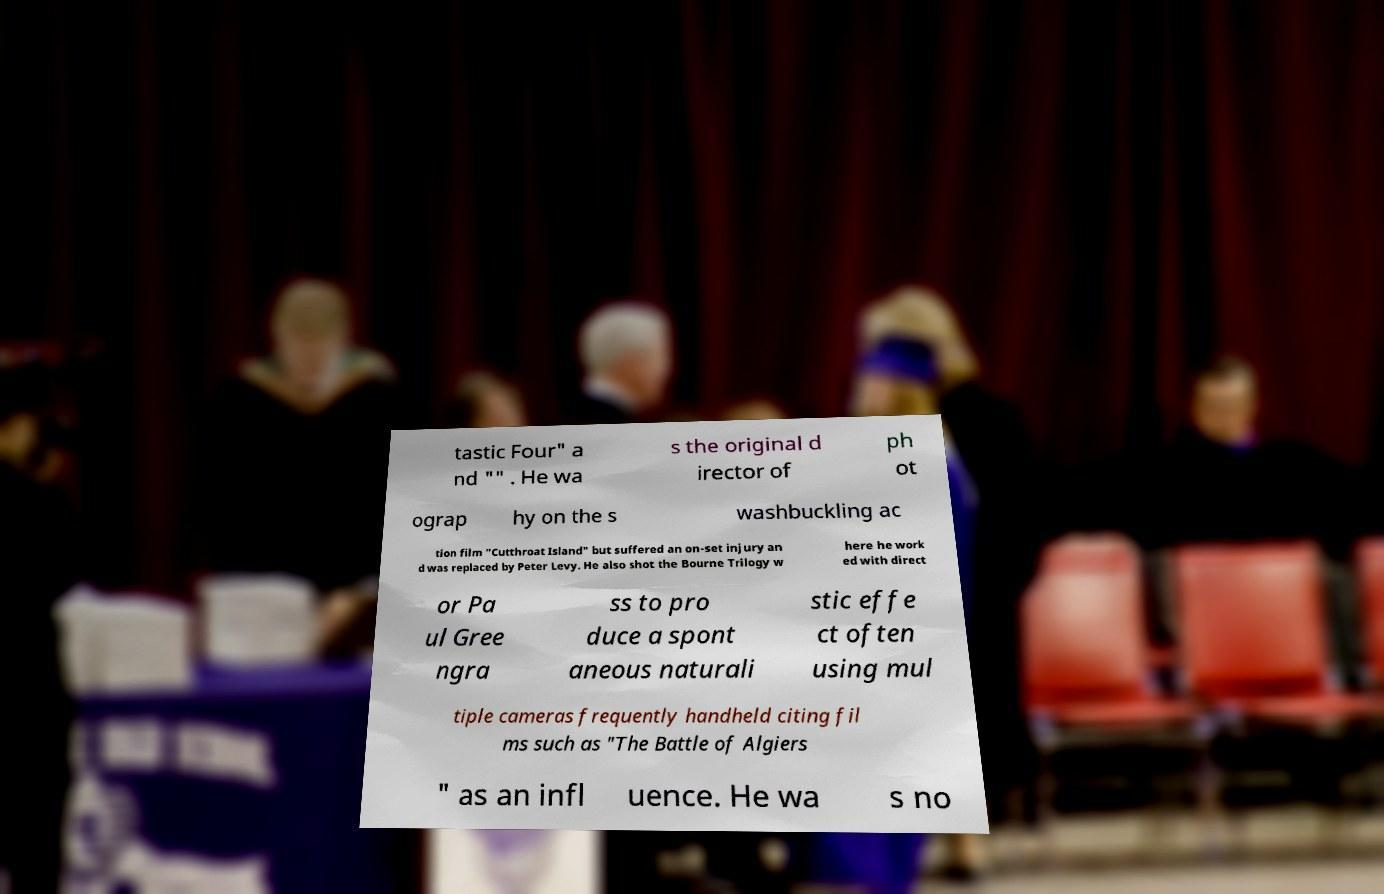Could you assist in decoding the text presented in this image and type it out clearly? tastic Four" a nd "" . He wa s the original d irector of ph ot ograp hy on the s washbuckling ac tion film "Cutthroat Island" but suffered an on-set injury an d was replaced by Peter Levy. He also shot the Bourne Trilogy w here he work ed with direct or Pa ul Gree ngra ss to pro duce a spont aneous naturali stic effe ct often using mul tiple cameras frequently handheld citing fil ms such as "The Battle of Algiers " as an infl uence. He wa s no 